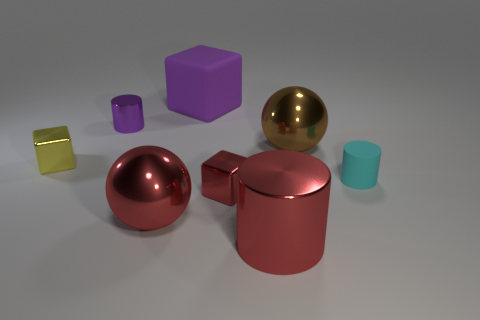Are there any large blue rubber objects that have the same shape as the brown metallic thing?
Offer a very short reply. No. What shape is the cyan thing that is the same size as the yellow object?
Your answer should be compact. Cylinder. There is a big shiny thing behind the small cyan thing; what shape is it?
Ensure brevity in your answer.  Sphere. Is the number of matte cylinders in front of the tiny red cube less than the number of large objects behind the cyan cylinder?
Your answer should be very brief. Yes. Does the red shiny sphere have the same size as the shiny cube on the left side of the small purple metal cylinder?
Offer a terse response. No. What number of red shiny things are the same size as the red cylinder?
Make the answer very short. 1. The big cylinder that is made of the same material as the yellow object is what color?
Offer a very short reply. Red. Is the number of small red metal cubes greater than the number of small green shiny balls?
Keep it short and to the point. Yes. Is the brown object made of the same material as the large cylinder?
Provide a succinct answer. Yes. There is a small purple thing that is the same material as the brown thing; what shape is it?
Make the answer very short. Cylinder. 